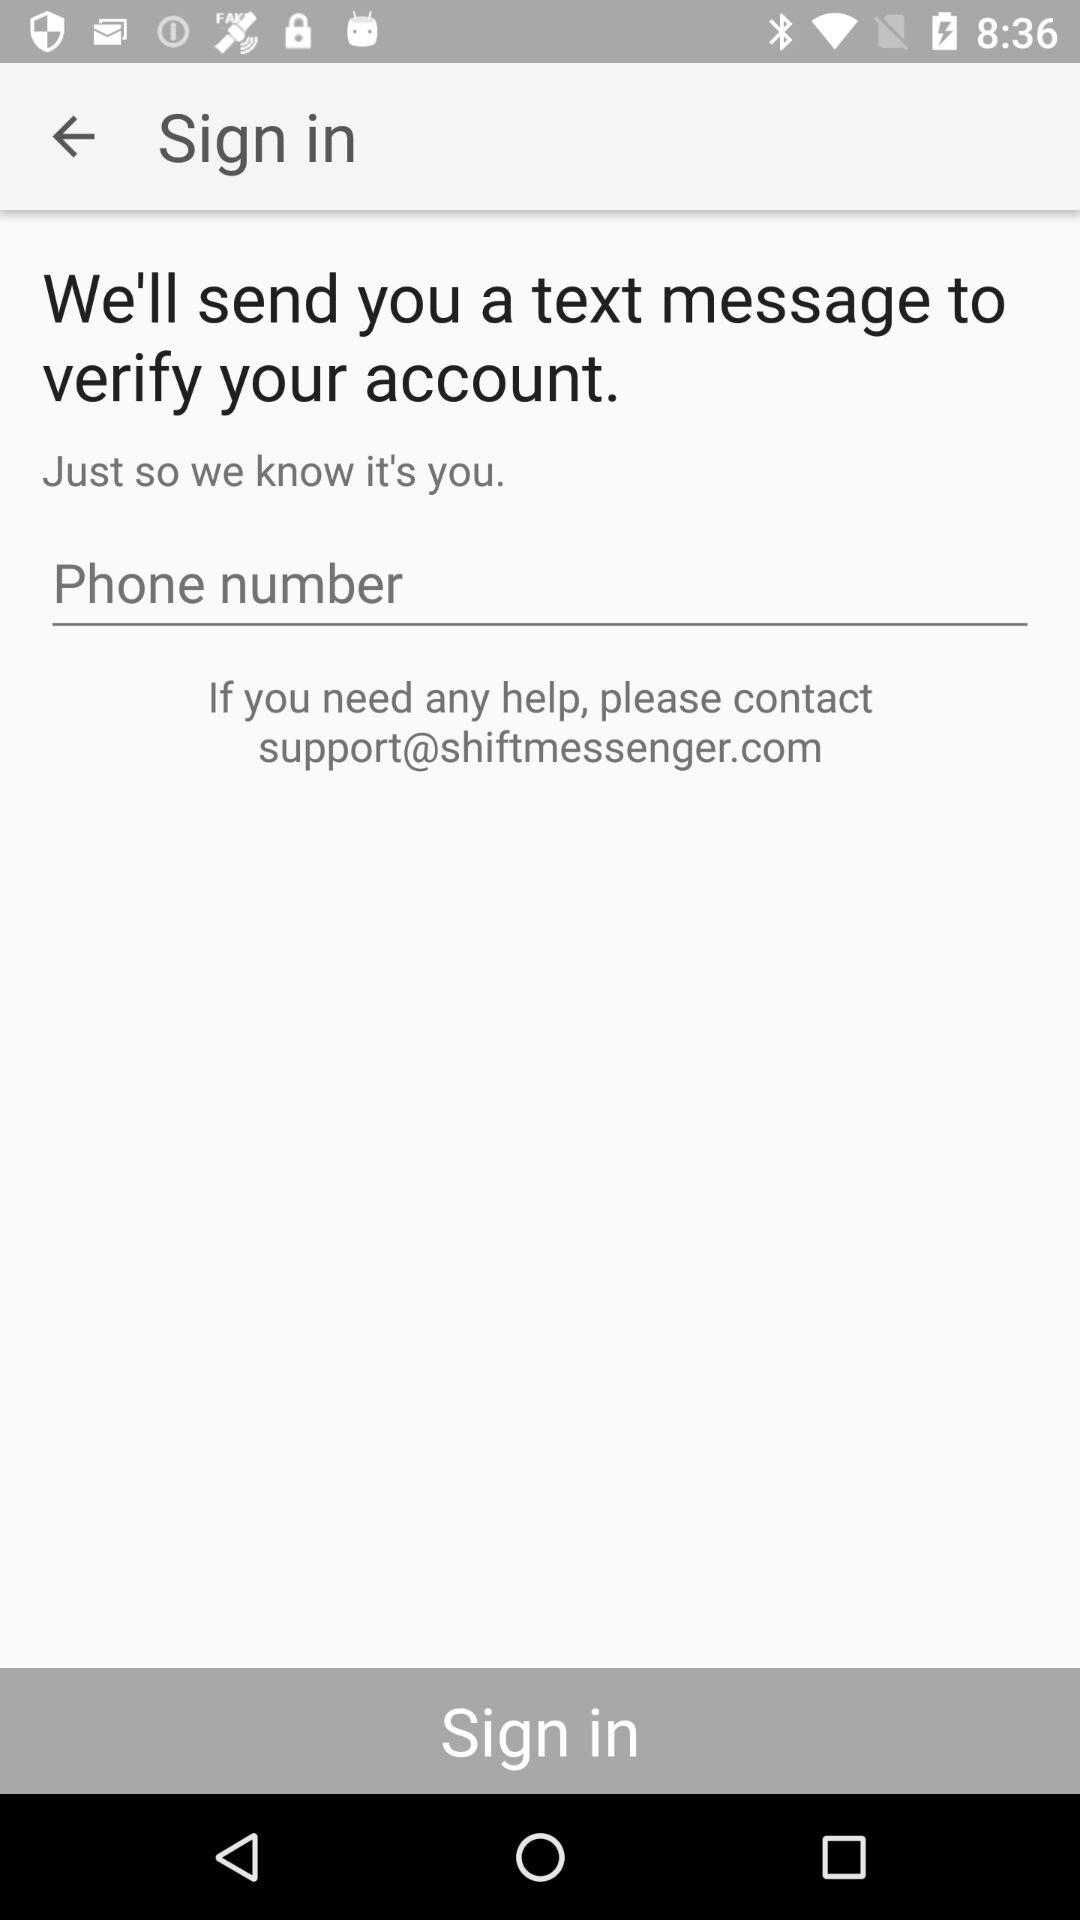How many numbers must be entered for the phone number?
When the provided information is insufficient, respond with <no answer>. <no answer> 